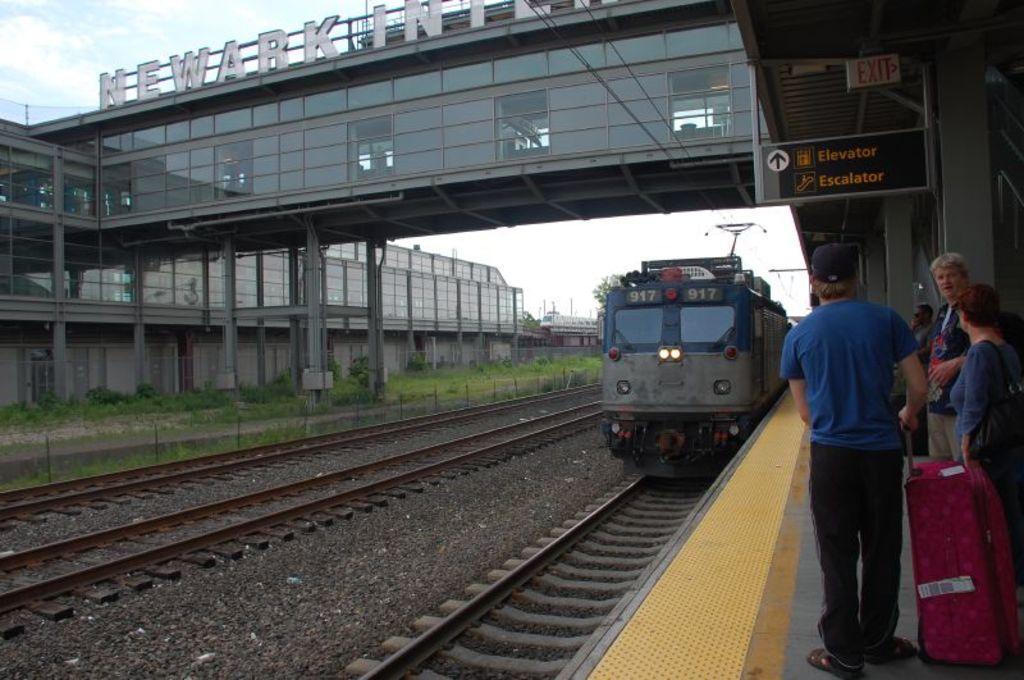In one or two sentences, can you explain what this image depicts? In the foreground I can see a group of people are standing on the platform and a train on the track. In the background I can see a bridge, text, board, grass, fence and the sky. This image is taken may be during a day. 